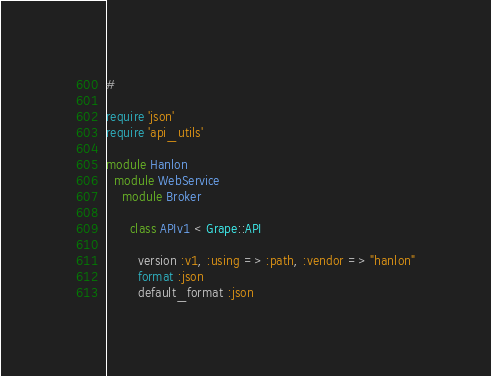Convert code to text. <code><loc_0><loc_0><loc_500><loc_500><_Ruby_>#

require 'json'
require 'api_utils'

module Hanlon
  module WebService
    module Broker

      class APIv1 < Grape::API

        version :v1, :using => :path, :vendor => "hanlon"
        format :json
        default_format :json</code> 